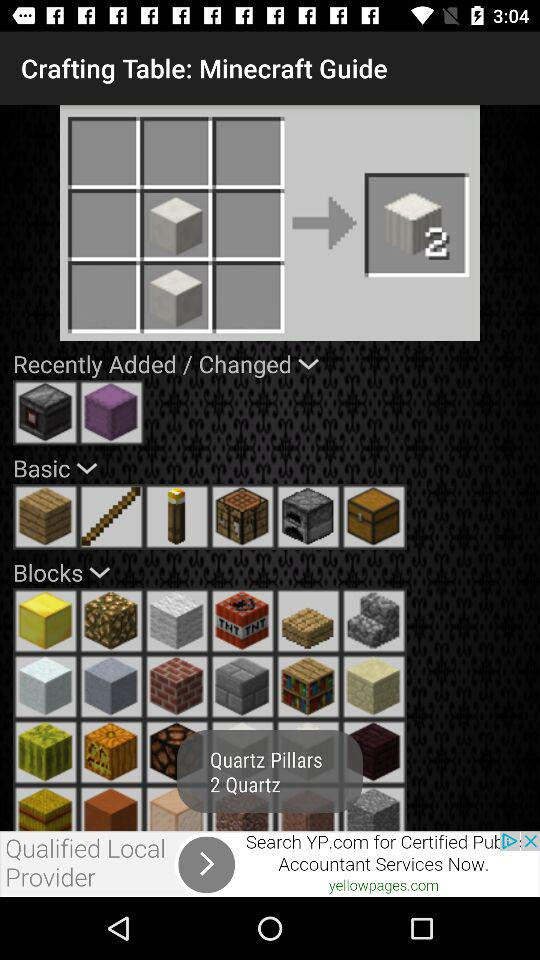How many quartz blocks are there in "Quartz Pillars"? There are 2 quartz blocks in "Quartz Pillars". 